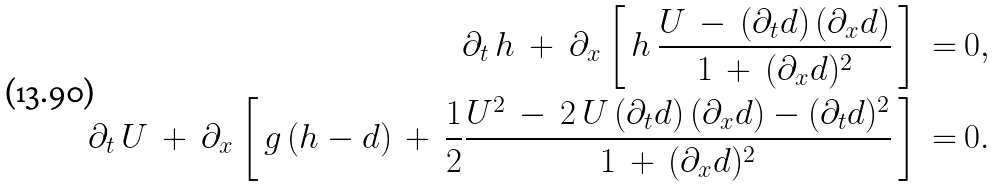Convert formula to latex. <formula><loc_0><loc_0><loc_500><loc_500>\partial _ { t } \, h \ + \ \partial _ { x } \left [ \, h \, \frac { U \, - \, ( \partial _ { t } \/ d ) \, ( \partial _ { x } \/ d ) } { 1 \, + \, ( \partial _ { x } \/ d ) ^ { 2 } } \, \right ] \, = & \ 0 , \\ \partial _ { t } \, U \ + \ \partial _ { x } \left [ \, g \, ( h - d ) \, + \, \frac { 1 } { 2 } \frac { U ^ { 2 } \, - \, 2 \, U \, ( \partial _ { t } \/ d ) \, ( \partial _ { x } \/ d ) - ( \partial _ { t } \/ d ) ^ { 2 } } { 1 \, + \, ( \partial _ { x } \/ d ) ^ { 2 } } \, \right ] \, = & \ 0 .</formula> 